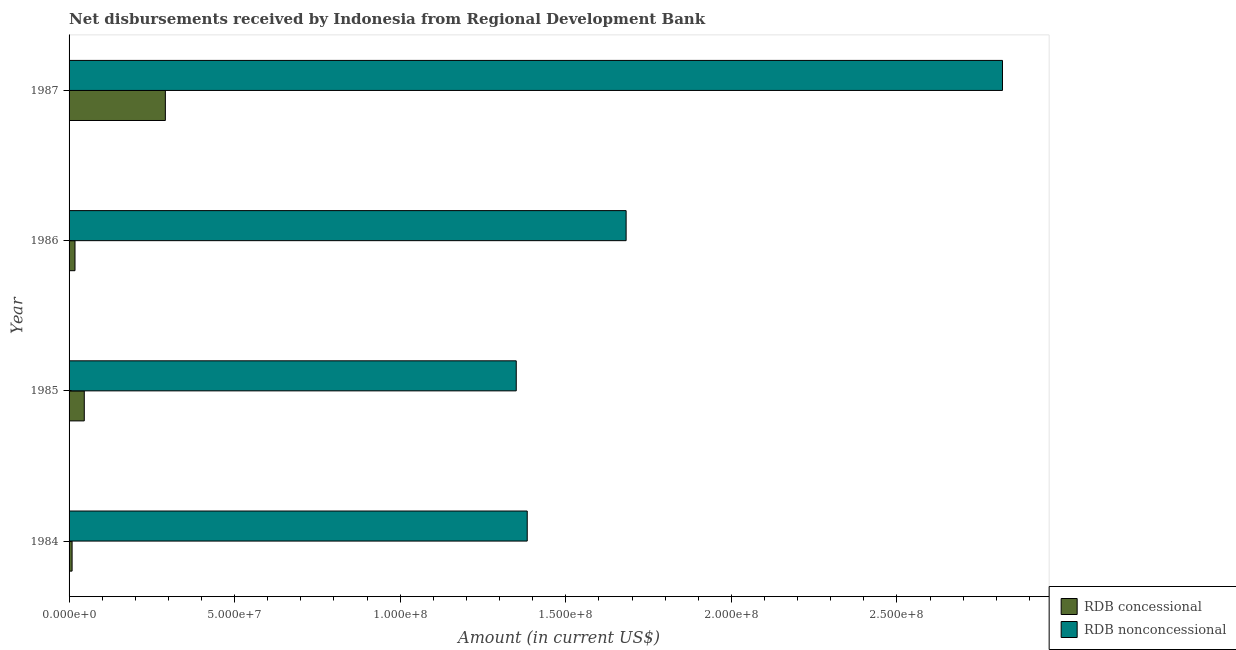How many different coloured bars are there?
Offer a terse response. 2. Are the number of bars on each tick of the Y-axis equal?
Provide a short and direct response. Yes. What is the label of the 4th group of bars from the top?
Keep it short and to the point. 1984. What is the net concessional disbursements from rdb in 1984?
Provide a short and direct response. 9.11e+05. Across all years, what is the maximum net non concessional disbursements from rdb?
Provide a succinct answer. 2.82e+08. Across all years, what is the minimum net concessional disbursements from rdb?
Your answer should be very brief. 9.11e+05. In which year was the net concessional disbursements from rdb minimum?
Make the answer very short. 1984. What is the total net non concessional disbursements from rdb in the graph?
Your answer should be compact. 7.23e+08. What is the difference between the net non concessional disbursements from rdb in 1985 and that in 1986?
Offer a very short reply. -3.32e+07. What is the difference between the net concessional disbursements from rdb in 1987 and the net non concessional disbursements from rdb in 1985?
Keep it short and to the point. -1.06e+08. What is the average net concessional disbursements from rdb per year?
Make the answer very short. 9.09e+06. In the year 1985, what is the difference between the net non concessional disbursements from rdb and net concessional disbursements from rdb?
Your response must be concise. 1.30e+08. In how many years, is the net concessional disbursements from rdb greater than 240000000 US$?
Keep it short and to the point. 0. What is the ratio of the net non concessional disbursements from rdb in 1984 to that in 1986?
Give a very brief answer. 0.82. Is the net concessional disbursements from rdb in 1984 less than that in 1987?
Your response must be concise. Yes. What is the difference between the highest and the second highest net concessional disbursements from rdb?
Offer a very short reply. 2.45e+07. What is the difference between the highest and the lowest net concessional disbursements from rdb?
Ensure brevity in your answer.  2.82e+07. Is the sum of the net concessional disbursements from rdb in 1985 and 1987 greater than the maximum net non concessional disbursements from rdb across all years?
Make the answer very short. No. What does the 2nd bar from the top in 1984 represents?
Keep it short and to the point. RDB concessional. What does the 1st bar from the bottom in 1985 represents?
Offer a very short reply. RDB concessional. Are all the bars in the graph horizontal?
Offer a very short reply. Yes. What is the difference between two consecutive major ticks on the X-axis?
Give a very brief answer. 5.00e+07. Are the values on the major ticks of X-axis written in scientific E-notation?
Give a very brief answer. Yes. Does the graph contain any zero values?
Keep it short and to the point. No. How many legend labels are there?
Keep it short and to the point. 2. What is the title of the graph?
Provide a succinct answer. Net disbursements received by Indonesia from Regional Development Bank. Does "Male entrants" appear as one of the legend labels in the graph?
Provide a short and direct response. No. What is the label or title of the Y-axis?
Give a very brief answer. Year. What is the Amount (in current US$) in RDB concessional in 1984?
Your response must be concise. 9.11e+05. What is the Amount (in current US$) of RDB nonconcessional in 1984?
Your response must be concise. 1.38e+08. What is the Amount (in current US$) of RDB concessional in 1985?
Offer a terse response. 4.59e+06. What is the Amount (in current US$) of RDB nonconcessional in 1985?
Give a very brief answer. 1.35e+08. What is the Amount (in current US$) in RDB concessional in 1986?
Ensure brevity in your answer.  1.79e+06. What is the Amount (in current US$) of RDB nonconcessional in 1986?
Your answer should be compact. 1.68e+08. What is the Amount (in current US$) in RDB concessional in 1987?
Make the answer very short. 2.91e+07. What is the Amount (in current US$) in RDB nonconcessional in 1987?
Provide a short and direct response. 2.82e+08. Across all years, what is the maximum Amount (in current US$) of RDB concessional?
Your answer should be very brief. 2.91e+07. Across all years, what is the maximum Amount (in current US$) in RDB nonconcessional?
Give a very brief answer. 2.82e+08. Across all years, what is the minimum Amount (in current US$) in RDB concessional?
Ensure brevity in your answer.  9.11e+05. Across all years, what is the minimum Amount (in current US$) of RDB nonconcessional?
Offer a very short reply. 1.35e+08. What is the total Amount (in current US$) of RDB concessional in the graph?
Give a very brief answer. 3.64e+07. What is the total Amount (in current US$) in RDB nonconcessional in the graph?
Your answer should be compact. 7.23e+08. What is the difference between the Amount (in current US$) of RDB concessional in 1984 and that in 1985?
Give a very brief answer. -3.68e+06. What is the difference between the Amount (in current US$) of RDB nonconcessional in 1984 and that in 1985?
Ensure brevity in your answer.  3.32e+06. What is the difference between the Amount (in current US$) of RDB concessional in 1984 and that in 1986?
Ensure brevity in your answer.  -8.81e+05. What is the difference between the Amount (in current US$) of RDB nonconcessional in 1984 and that in 1986?
Your answer should be compact. -2.99e+07. What is the difference between the Amount (in current US$) in RDB concessional in 1984 and that in 1987?
Provide a short and direct response. -2.82e+07. What is the difference between the Amount (in current US$) in RDB nonconcessional in 1984 and that in 1987?
Your answer should be compact. -1.44e+08. What is the difference between the Amount (in current US$) in RDB concessional in 1985 and that in 1986?
Your answer should be very brief. 2.80e+06. What is the difference between the Amount (in current US$) in RDB nonconcessional in 1985 and that in 1986?
Give a very brief answer. -3.32e+07. What is the difference between the Amount (in current US$) of RDB concessional in 1985 and that in 1987?
Provide a succinct answer. -2.45e+07. What is the difference between the Amount (in current US$) in RDB nonconcessional in 1985 and that in 1987?
Make the answer very short. -1.47e+08. What is the difference between the Amount (in current US$) of RDB concessional in 1986 and that in 1987?
Give a very brief answer. -2.73e+07. What is the difference between the Amount (in current US$) in RDB nonconcessional in 1986 and that in 1987?
Your answer should be compact. -1.14e+08. What is the difference between the Amount (in current US$) of RDB concessional in 1984 and the Amount (in current US$) of RDB nonconcessional in 1985?
Provide a succinct answer. -1.34e+08. What is the difference between the Amount (in current US$) of RDB concessional in 1984 and the Amount (in current US$) of RDB nonconcessional in 1986?
Offer a very short reply. -1.67e+08. What is the difference between the Amount (in current US$) in RDB concessional in 1984 and the Amount (in current US$) in RDB nonconcessional in 1987?
Your response must be concise. -2.81e+08. What is the difference between the Amount (in current US$) of RDB concessional in 1985 and the Amount (in current US$) of RDB nonconcessional in 1986?
Make the answer very short. -1.64e+08. What is the difference between the Amount (in current US$) in RDB concessional in 1985 and the Amount (in current US$) in RDB nonconcessional in 1987?
Offer a very short reply. -2.77e+08. What is the difference between the Amount (in current US$) of RDB concessional in 1986 and the Amount (in current US$) of RDB nonconcessional in 1987?
Make the answer very short. -2.80e+08. What is the average Amount (in current US$) in RDB concessional per year?
Offer a very short reply. 9.09e+06. What is the average Amount (in current US$) of RDB nonconcessional per year?
Ensure brevity in your answer.  1.81e+08. In the year 1984, what is the difference between the Amount (in current US$) of RDB concessional and Amount (in current US$) of RDB nonconcessional?
Your answer should be compact. -1.37e+08. In the year 1985, what is the difference between the Amount (in current US$) of RDB concessional and Amount (in current US$) of RDB nonconcessional?
Your answer should be compact. -1.30e+08. In the year 1986, what is the difference between the Amount (in current US$) in RDB concessional and Amount (in current US$) in RDB nonconcessional?
Make the answer very short. -1.66e+08. In the year 1987, what is the difference between the Amount (in current US$) in RDB concessional and Amount (in current US$) in RDB nonconcessional?
Ensure brevity in your answer.  -2.53e+08. What is the ratio of the Amount (in current US$) in RDB concessional in 1984 to that in 1985?
Your answer should be very brief. 0.2. What is the ratio of the Amount (in current US$) of RDB nonconcessional in 1984 to that in 1985?
Your response must be concise. 1.02. What is the ratio of the Amount (in current US$) in RDB concessional in 1984 to that in 1986?
Keep it short and to the point. 0.51. What is the ratio of the Amount (in current US$) in RDB nonconcessional in 1984 to that in 1986?
Offer a terse response. 0.82. What is the ratio of the Amount (in current US$) in RDB concessional in 1984 to that in 1987?
Give a very brief answer. 0.03. What is the ratio of the Amount (in current US$) of RDB nonconcessional in 1984 to that in 1987?
Offer a terse response. 0.49. What is the ratio of the Amount (in current US$) of RDB concessional in 1985 to that in 1986?
Offer a very short reply. 2.56. What is the ratio of the Amount (in current US$) in RDB nonconcessional in 1985 to that in 1986?
Provide a succinct answer. 0.8. What is the ratio of the Amount (in current US$) of RDB concessional in 1985 to that in 1987?
Give a very brief answer. 0.16. What is the ratio of the Amount (in current US$) of RDB nonconcessional in 1985 to that in 1987?
Offer a very short reply. 0.48. What is the ratio of the Amount (in current US$) of RDB concessional in 1986 to that in 1987?
Give a very brief answer. 0.06. What is the ratio of the Amount (in current US$) in RDB nonconcessional in 1986 to that in 1987?
Offer a very short reply. 0.6. What is the difference between the highest and the second highest Amount (in current US$) of RDB concessional?
Give a very brief answer. 2.45e+07. What is the difference between the highest and the second highest Amount (in current US$) in RDB nonconcessional?
Provide a short and direct response. 1.14e+08. What is the difference between the highest and the lowest Amount (in current US$) in RDB concessional?
Ensure brevity in your answer.  2.82e+07. What is the difference between the highest and the lowest Amount (in current US$) in RDB nonconcessional?
Ensure brevity in your answer.  1.47e+08. 